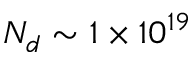<formula> <loc_0><loc_0><loc_500><loc_500>N _ { d } \sim 1 \times 1 0 ^ { 1 9 }</formula> 